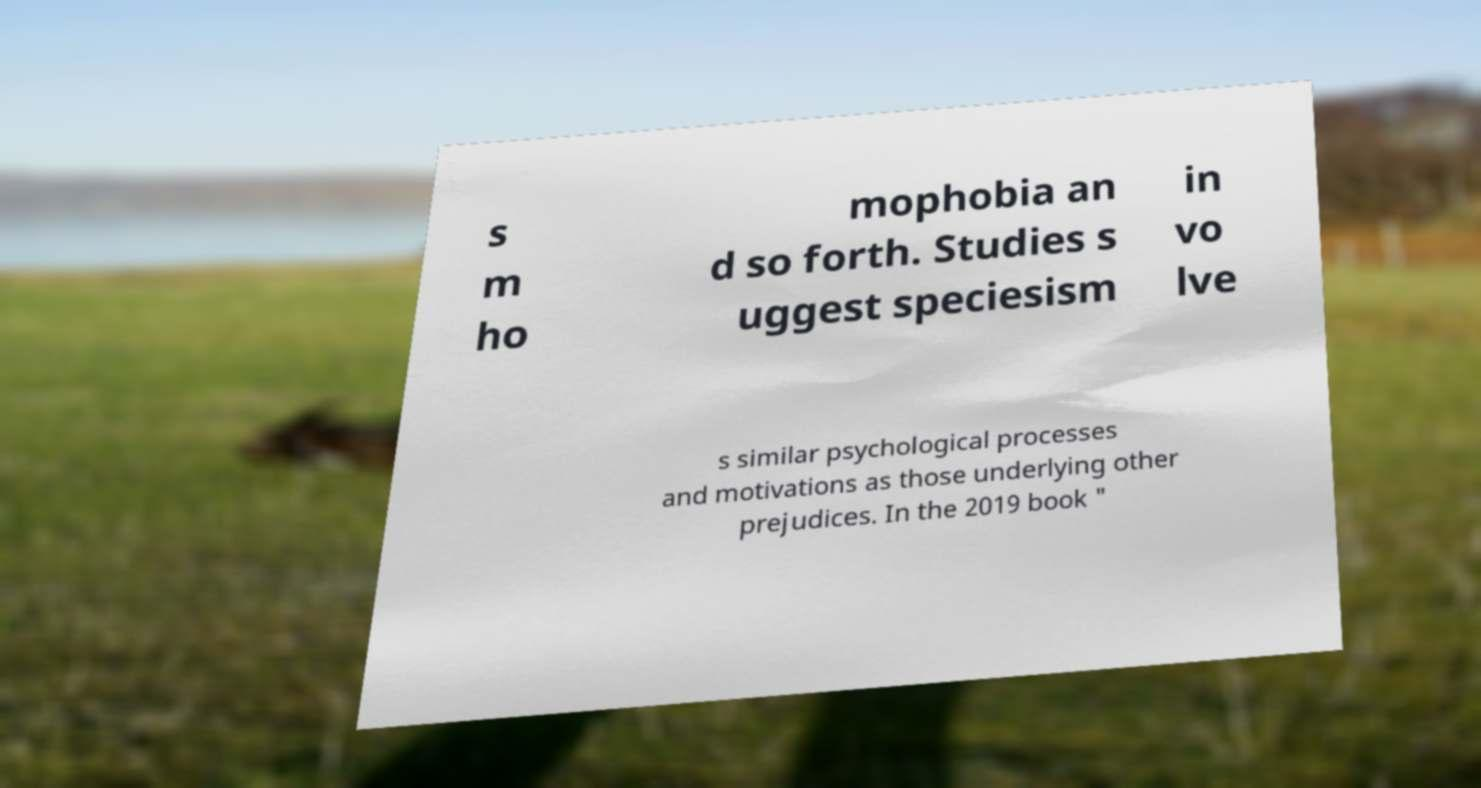Please identify and transcribe the text found in this image. s m ho mophobia an d so forth. Studies s uggest speciesism in vo lve s similar psychological processes and motivations as those underlying other prejudices. In the 2019 book " 